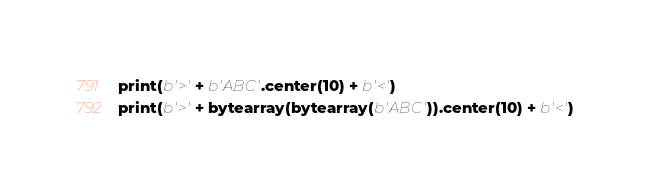<code> <loc_0><loc_0><loc_500><loc_500><_Python_>print(b'>' + b'ABC'.center(10) + b'<')
print(b'>' + bytearray(bytearray(b'ABC')).center(10) + b'<')
</code> 